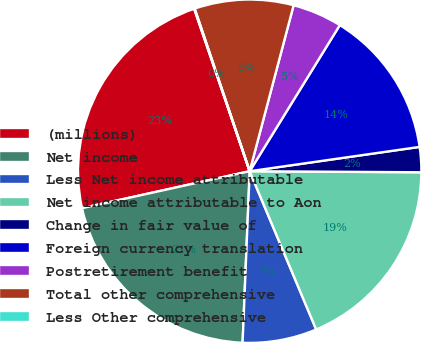<chart> <loc_0><loc_0><loc_500><loc_500><pie_chart><fcel>(millions)<fcel>Net income<fcel>Less Net income attributable<fcel>Net income attributable to Aon<fcel>Change in fair value of<fcel>Foreign currency translation<fcel>Postretirement benefit<fcel>Total other comprehensive<fcel>Less Other comprehensive<nl><fcel>23.21%<fcel>20.89%<fcel>6.99%<fcel>18.57%<fcel>2.36%<fcel>13.94%<fcel>4.68%<fcel>9.31%<fcel>0.05%<nl></chart> 